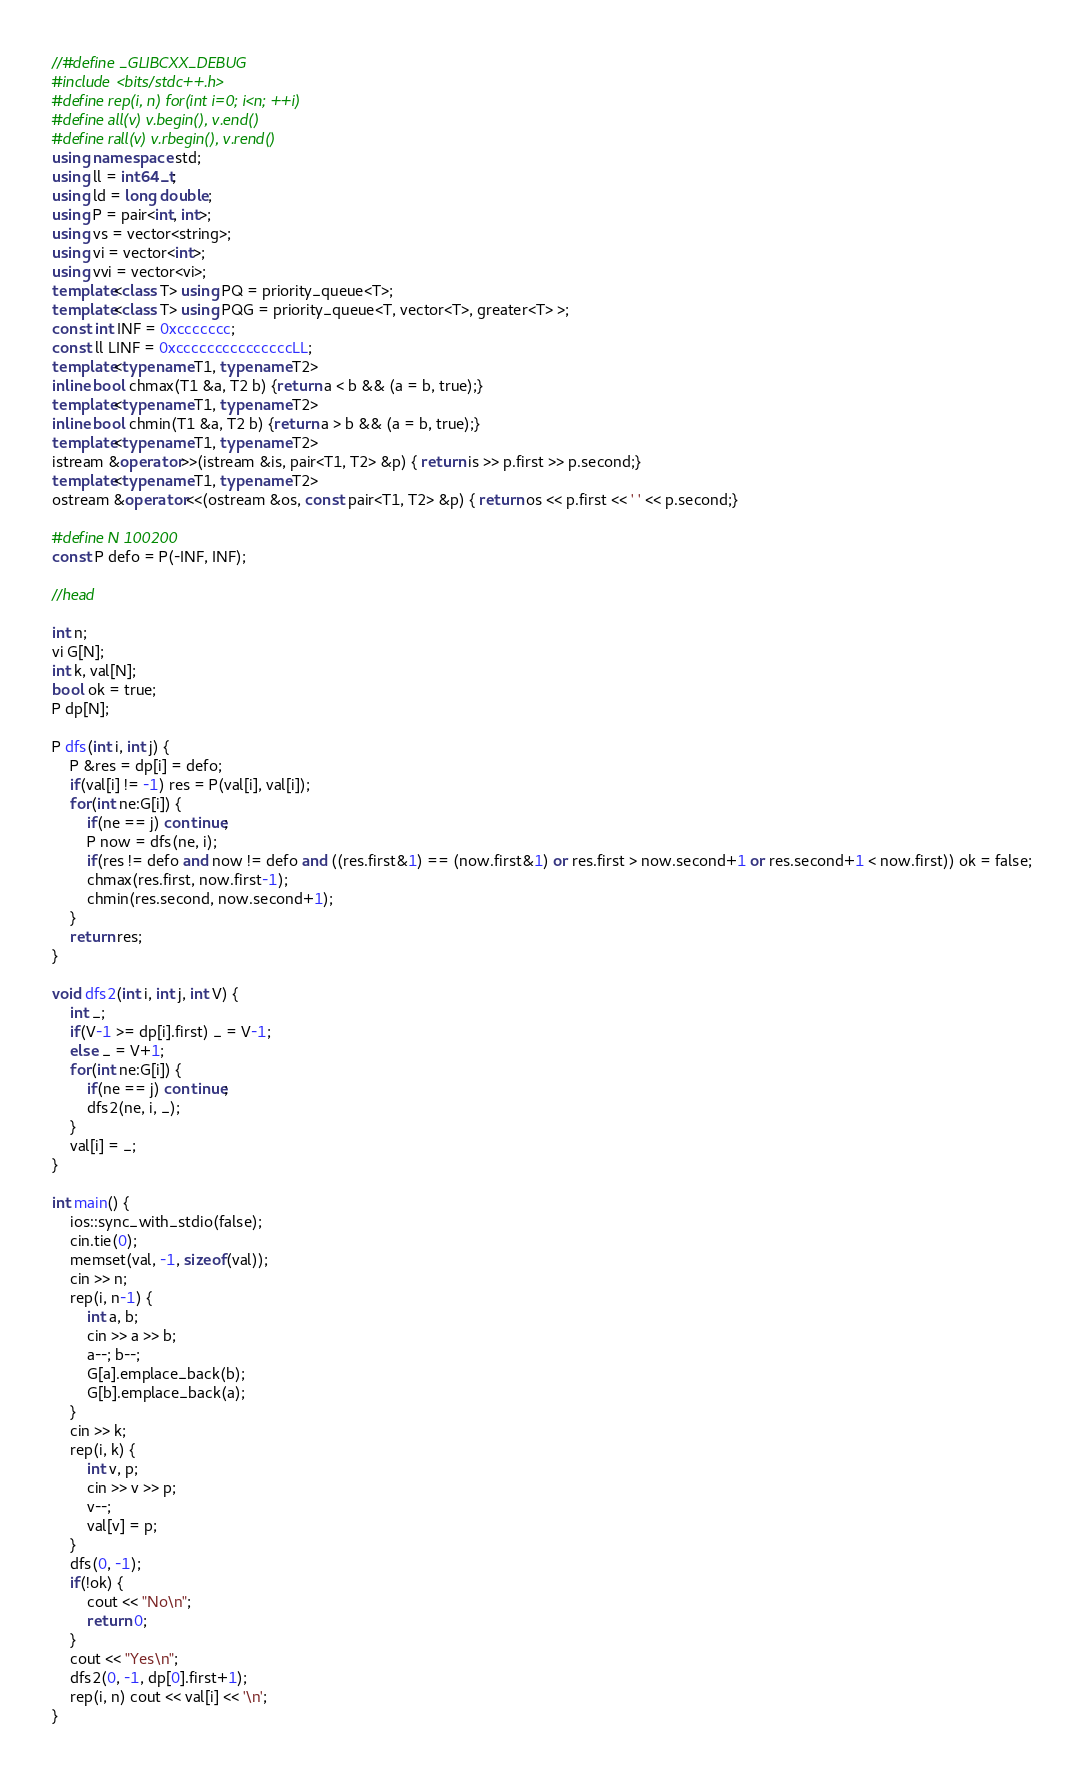Convert code to text. <code><loc_0><loc_0><loc_500><loc_500><_C++_>//#define _GLIBCXX_DEBUG
#include <bits/stdc++.h>
#define rep(i, n) for(int i=0; i<n; ++i)
#define all(v) v.begin(), v.end()
#define rall(v) v.rbegin(), v.rend()
using namespace std;
using ll = int64_t;
using ld = long double;
using P = pair<int, int>;
using vs = vector<string>;
using vi = vector<int>;
using vvi = vector<vi>;
template<class T> using PQ = priority_queue<T>;
template<class T> using PQG = priority_queue<T, vector<T>, greater<T> >;
const int INF = 0xccccccc;
const ll LINF = 0xcccccccccccccccLL;
template<typename T1, typename T2>
inline bool chmax(T1 &a, T2 b) {return a < b && (a = b, true);}
template<typename T1, typename T2>
inline bool chmin(T1 &a, T2 b) {return a > b && (a = b, true);}
template<typename T1, typename T2>
istream &operator>>(istream &is, pair<T1, T2> &p) { return is >> p.first >> p.second;}
template<typename T1, typename T2>
ostream &operator<<(ostream &os, const pair<T1, T2> &p) { return os << p.first << ' ' << p.second;}

#define N 100200
const P defo = P(-INF, INF);

//head

int n;
vi G[N];
int k, val[N];
bool ok = true;
P dp[N];

P dfs(int i, int j) {
	P &res = dp[i] = defo;
	if(val[i] != -1) res = P(val[i], val[i]);
	for(int ne:G[i]) {
		if(ne == j) continue;
		P now = dfs(ne, i);
		if(res != defo and now != defo and ((res.first&1) == (now.first&1) or res.first > now.second+1 or res.second+1 < now.first)) ok = false;
		chmax(res.first, now.first-1);
		chmin(res.second, now.second+1);
	}
	return res;
}

void dfs2(int i, int j, int V) {
	int _;
	if(V-1 >= dp[i].first) _ = V-1;
	else _ = V+1;
	for(int ne:G[i]) {
		if(ne == j) continue;
		dfs2(ne, i, _);
	}
	val[i] = _;
}

int main() {
	ios::sync_with_stdio(false);
	cin.tie(0);
	memset(val, -1, sizeof(val));
	cin >> n;
	rep(i, n-1) {
		int a, b;
		cin >> a >> b;
		a--; b--;
		G[a].emplace_back(b);
		G[b].emplace_back(a);
	}
	cin >> k;
	rep(i, k) {
		int v, p;
		cin >> v >> p;
		v--;
		val[v] = p;
	}
	dfs(0, -1);
	if(!ok) {
		cout << "No\n";
		return 0;
	}
	cout << "Yes\n";
	dfs2(0, -1, dp[0].first+1);
	rep(i, n) cout << val[i] << '\n';
}</code> 